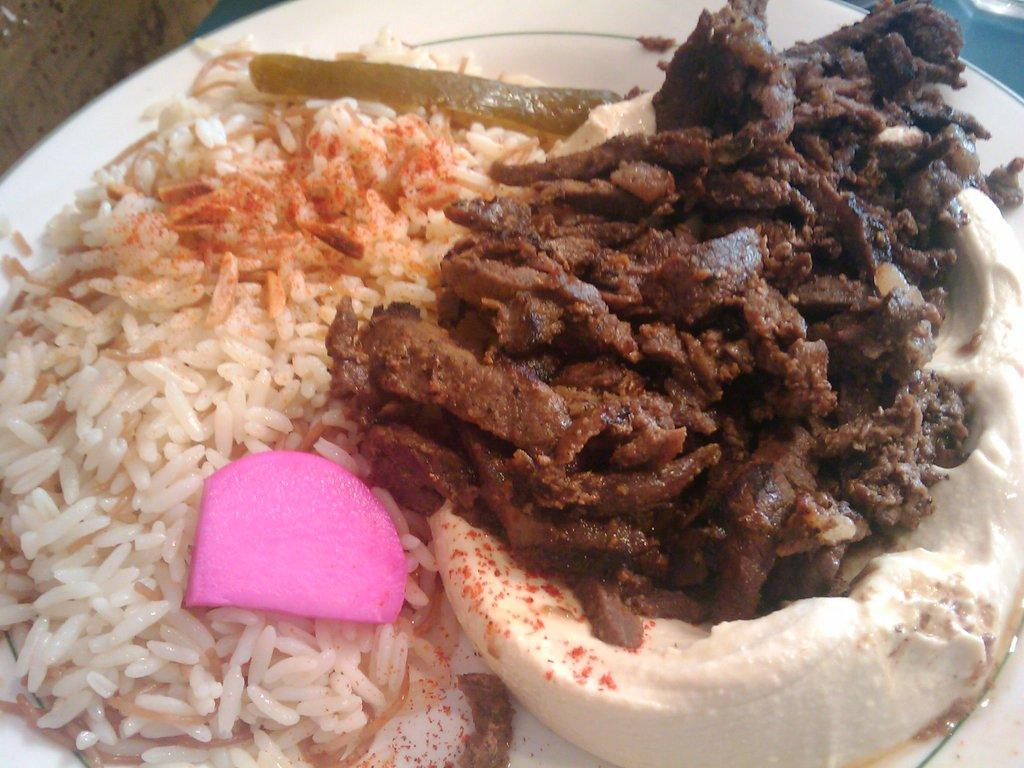What is on the plate that is visible in the image? There is rice on the plate in the image. What other food item can be seen in the image? There is a food item of white and brown color in the image. What color is the object that is not a food item in the image? There is a pink object in the image. How does the toothbrush help in locking the door in the image? There is no toothbrush or lock present in the image. 